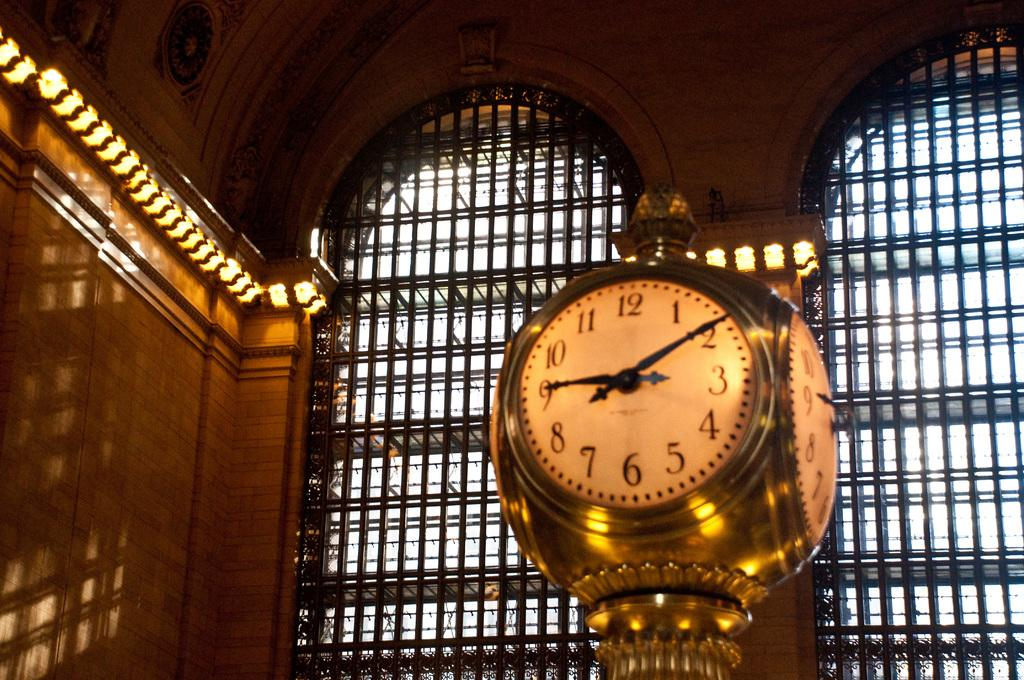<image>
Describe the image concisely. A clock with the time 9:10 on it. 